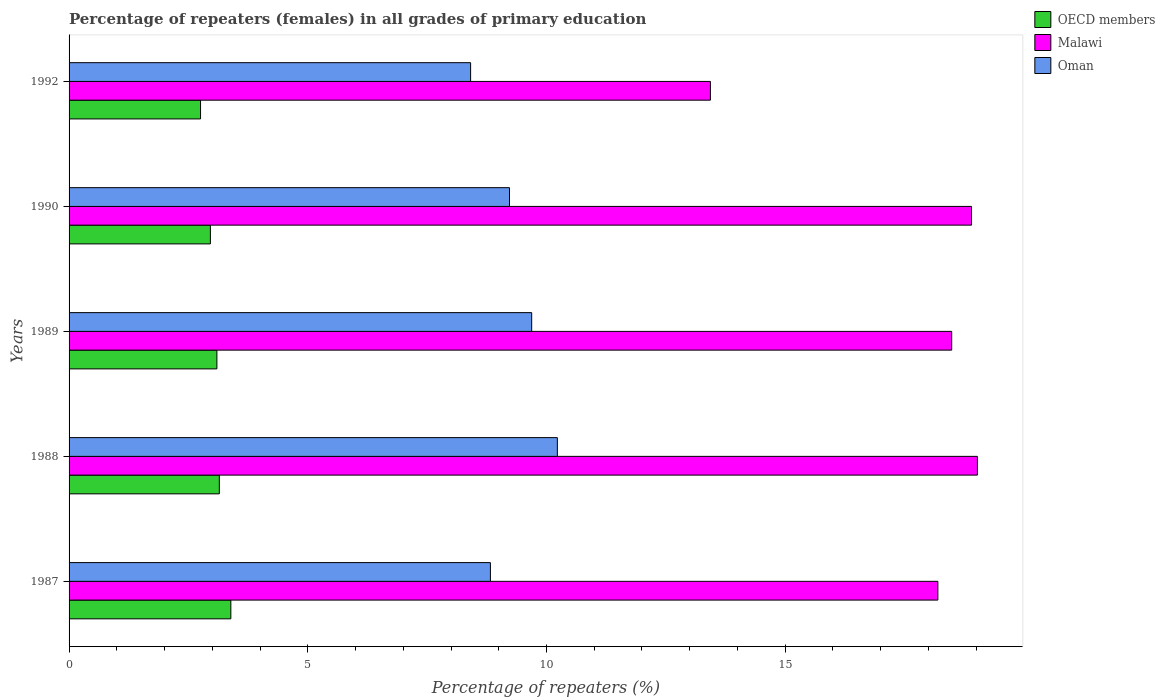How many groups of bars are there?
Give a very brief answer. 5. How many bars are there on the 5th tick from the bottom?
Give a very brief answer. 3. What is the label of the 3rd group of bars from the top?
Offer a terse response. 1989. What is the percentage of repeaters (females) in Malawi in 1992?
Your answer should be very brief. 13.43. Across all years, what is the maximum percentage of repeaters (females) in OECD members?
Ensure brevity in your answer.  3.39. Across all years, what is the minimum percentage of repeaters (females) in OECD members?
Provide a succinct answer. 2.75. What is the total percentage of repeaters (females) in OECD members in the graph?
Provide a succinct answer. 15.35. What is the difference between the percentage of repeaters (females) in OECD members in 1990 and that in 1992?
Provide a succinct answer. 0.21. What is the difference between the percentage of repeaters (females) in OECD members in 1990 and the percentage of repeaters (females) in Malawi in 1989?
Keep it short and to the point. -15.53. What is the average percentage of repeaters (females) in OECD members per year?
Make the answer very short. 3.07. In the year 1992, what is the difference between the percentage of repeaters (females) in Malawi and percentage of repeaters (females) in OECD members?
Provide a short and direct response. 10.68. What is the ratio of the percentage of repeaters (females) in Malawi in 1988 to that in 1992?
Your response must be concise. 1.42. Is the percentage of repeaters (females) in OECD members in 1988 less than that in 1990?
Provide a short and direct response. No. What is the difference between the highest and the second highest percentage of repeaters (females) in Malawi?
Give a very brief answer. 0.12. What is the difference between the highest and the lowest percentage of repeaters (females) in OECD members?
Ensure brevity in your answer.  0.63. In how many years, is the percentage of repeaters (females) in Oman greater than the average percentage of repeaters (females) in Oman taken over all years?
Provide a short and direct response. 2. What does the 2nd bar from the top in 1988 represents?
Offer a terse response. Malawi. What does the 3rd bar from the bottom in 1988 represents?
Keep it short and to the point. Oman. Is it the case that in every year, the sum of the percentage of repeaters (females) in Oman and percentage of repeaters (females) in Malawi is greater than the percentage of repeaters (females) in OECD members?
Provide a succinct answer. Yes. Are all the bars in the graph horizontal?
Your response must be concise. Yes. How many years are there in the graph?
Your answer should be very brief. 5. What is the difference between two consecutive major ticks on the X-axis?
Your answer should be very brief. 5. Does the graph contain any zero values?
Offer a very short reply. No. Does the graph contain grids?
Your answer should be compact. No. Where does the legend appear in the graph?
Give a very brief answer. Top right. How are the legend labels stacked?
Your response must be concise. Vertical. What is the title of the graph?
Offer a terse response. Percentage of repeaters (females) in all grades of primary education. What is the label or title of the X-axis?
Your answer should be compact. Percentage of repeaters (%). What is the Percentage of repeaters (%) in OECD members in 1987?
Give a very brief answer. 3.39. What is the Percentage of repeaters (%) of Malawi in 1987?
Your answer should be very brief. 18.2. What is the Percentage of repeaters (%) in Oman in 1987?
Your answer should be very brief. 8.83. What is the Percentage of repeaters (%) of OECD members in 1988?
Provide a short and direct response. 3.15. What is the Percentage of repeaters (%) of Malawi in 1988?
Make the answer very short. 19.03. What is the Percentage of repeaters (%) of Oman in 1988?
Ensure brevity in your answer.  10.23. What is the Percentage of repeaters (%) in OECD members in 1989?
Offer a very short reply. 3.1. What is the Percentage of repeaters (%) of Malawi in 1989?
Give a very brief answer. 18.49. What is the Percentage of repeaters (%) of Oman in 1989?
Your answer should be very brief. 9.69. What is the Percentage of repeaters (%) in OECD members in 1990?
Make the answer very short. 2.96. What is the Percentage of repeaters (%) of Malawi in 1990?
Make the answer very short. 18.9. What is the Percentage of repeaters (%) of Oman in 1990?
Ensure brevity in your answer.  9.23. What is the Percentage of repeaters (%) of OECD members in 1992?
Keep it short and to the point. 2.75. What is the Percentage of repeaters (%) in Malawi in 1992?
Provide a short and direct response. 13.43. What is the Percentage of repeaters (%) in Oman in 1992?
Give a very brief answer. 8.41. Across all years, what is the maximum Percentage of repeaters (%) of OECD members?
Your answer should be compact. 3.39. Across all years, what is the maximum Percentage of repeaters (%) in Malawi?
Provide a succinct answer. 19.03. Across all years, what is the maximum Percentage of repeaters (%) in Oman?
Provide a succinct answer. 10.23. Across all years, what is the minimum Percentage of repeaters (%) in OECD members?
Your answer should be compact. 2.75. Across all years, what is the minimum Percentage of repeaters (%) in Malawi?
Offer a terse response. 13.43. Across all years, what is the minimum Percentage of repeaters (%) of Oman?
Your response must be concise. 8.41. What is the total Percentage of repeaters (%) of OECD members in the graph?
Give a very brief answer. 15.35. What is the total Percentage of repeaters (%) of Malawi in the graph?
Provide a short and direct response. 88.05. What is the total Percentage of repeaters (%) in Oman in the graph?
Keep it short and to the point. 46.38. What is the difference between the Percentage of repeaters (%) of OECD members in 1987 and that in 1988?
Offer a very short reply. 0.24. What is the difference between the Percentage of repeaters (%) of Malawi in 1987 and that in 1988?
Offer a terse response. -0.83. What is the difference between the Percentage of repeaters (%) of Oman in 1987 and that in 1988?
Make the answer very short. -1.4. What is the difference between the Percentage of repeaters (%) in OECD members in 1987 and that in 1989?
Your answer should be very brief. 0.29. What is the difference between the Percentage of repeaters (%) in Malawi in 1987 and that in 1989?
Provide a short and direct response. -0.29. What is the difference between the Percentage of repeaters (%) in Oman in 1987 and that in 1989?
Make the answer very short. -0.86. What is the difference between the Percentage of repeaters (%) of OECD members in 1987 and that in 1990?
Make the answer very short. 0.43. What is the difference between the Percentage of repeaters (%) in Malawi in 1987 and that in 1990?
Offer a very short reply. -0.7. What is the difference between the Percentage of repeaters (%) in Oman in 1987 and that in 1990?
Provide a short and direct response. -0.4. What is the difference between the Percentage of repeaters (%) in OECD members in 1987 and that in 1992?
Your answer should be compact. 0.63. What is the difference between the Percentage of repeaters (%) in Malawi in 1987 and that in 1992?
Offer a very short reply. 4.76. What is the difference between the Percentage of repeaters (%) in Oman in 1987 and that in 1992?
Offer a terse response. 0.41. What is the difference between the Percentage of repeaters (%) in OECD members in 1988 and that in 1989?
Provide a short and direct response. 0.05. What is the difference between the Percentage of repeaters (%) of Malawi in 1988 and that in 1989?
Your answer should be compact. 0.54. What is the difference between the Percentage of repeaters (%) in Oman in 1988 and that in 1989?
Make the answer very short. 0.54. What is the difference between the Percentage of repeaters (%) of OECD members in 1988 and that in 1990?
Your response must be concise. 0.19. What is the difference between the Percentage of repeaters (%) of Malawi in 1988 and that in 1990?
Ensure brevity in your answer.  0.12. What is the difference between the Percentage of repeaters (%) in Oman in 1988 and that in 1990?
Keep it short and to the point. 1. What is the difference between the Percentage of repeaters (%) of OECD members in 1988 and that in 1992?
Your answer should be compact. 0.39. What is the difference between the Percentage of repeaters (%) in Malawi in 1988 and that in 1992?
Make the answer very short. 5.59. What is the difference between the Percentage of repeaters (%) in Oman in 1988 and that in 1992?
Offer a terse response. 1.82. What is the difference between the Percentage of repeaters (%) of OECD members in 1989 and that in 1990?
Keep it short and to the point. 0.14. What is the difference between the Percentage of repeaters (%) in Malawi in 1989 and that in 1990?
Give a very brief answer. -0.41. What is the difference between the Percentage of repeaters (%) in Oman in 1989 and that in 1990?
Offer a very short reply. 0.46. What is the difference between the Percentage of repeaters (%) of OECD members in 1989 and that in 1992?
Offer a very short reply. 0.34. What is the difference between the Percentage of repeaters (%) of Malawi in 1989 and that in 1992?
Keep it short and to the point. 5.05. What is the difference between the Percentage of repeaters (%) of Oman in 1989 and that in 1992?
Your answer should be very brief. 1.28. What is the difference between the Percentage of repeaters (%) of OECD members in 1990 and that in 1992?
Provide a succinct answer. 0.21. What is the difference between the Percentage of repeaters (%) of Malawi in 1990 and that in 1992?
Give a very brief answer. 5.47. What is the difference between the Percentage of repeaters (%) in Oman in 1990 and that in 1992?
Give a very brief answer. 0.81. What is the difference between the Percentage of repeaters (%) of OECD members in 1987 and the Percentage of repeaters (%) of Malawi in 1988?
Your response must be concise. -15.64. What is the difference between the Percentage of repeaters (%) of OECD members in 1987 and the Percentage of repeaters (%) of Oman in 1988?
Keep it short and to the point. -6.84. What is the difference between the Percentage of repeaters (%) in Malawi in 1987 and the Percentage of repeaters (%) in Oman in 1988?
Offer a terse response. 7.97. What is the difference between the Percentage of repeaters (%) in OECD members in 1987 and the Percentage of repeaters (%) in Malawi in 1989?
Give a very brief answer. -15.1. What is the difference between the Percentage of repeaters (%) of OECD members in 1987 and the Percentage of repeaters (%) of Oman in 1989?
Provide a short and direct response. -6.3. What is the difference between the Percentage of repeaters (%) of Malawi in 1987 and the Percentage of repeaters (%) of Oman in 1989?
Keep it short and to the point. 8.51. What is the difference between the Percentage of repeaters (%) in OECD members in 1987 and the Percentage of repeaters (%) in Malawi in 1990?
Offer a very short reply. -15.51. What is the difference between the Percentage of repeaters (%) of OECD members in 1987 and the Percentage of repeaters (%) of Oman in 1990?
Offer a very short reply. -5.84. What is the difference between the Percentage of repeaters (%) of Malawi in 1987 and the Percentage of repeaters (%) of Oman in 1990?
Your answer should be compact. 8.97. What is the difference between the Percentage of repeaters (%) of OECD members in 1987 and the Percentage of repeaters (%) of Malawi in 1992?
Give a very brief answer. -10.05. What is the difference between the Percentage of repeaters (%) of OECD members in 1987 and the Percentage of repeaters (%) of Oman in 1992?
Offer a terse response. -5.02. What is the difference between the Percentage of repeaters (%) in Malawi in 1987 and the Percentage of repeaters (%) in Oman in 1992?
Your response must be concise. 9.79. What is the difference between the Percentage of repeaters (%) in OECD members in 1988 and the Percentage of repeaters (%) in Malawi in 1989?
Ensure brevity in your answer.  -15.34. What is the difference between the Percentage of repeaters (%) in OECD members in 1988 and the Percentage of repeaters (%) in Oman in 1989?
Keep it short and to the point. -6.54. What is the difference between the Percentage of repeaters (%) in Malawi in 1988 and the Percentage of repeaters (%) in Oman in 1989?
Give a very brief answer. 9.34. What is the difference between the Percentage of repeaters (%) of OECD members in 1988 and the Percentage of repeaters (%) of Malawi in 1990?
Offer a very short reply. -15.76. What is the difference between the Percentage of repeaters (%) of OECD members in 1988 and the Percentage of repeaters (%) of Oman in 1990?
Provide a short and direct response. -6.08. What is the difference between the Percentage of repeaters (%) of Malawi in 1988 and the Percentage of repeaters (%) of Oman in 1990?
Make the answer very short. 9.8. What is the difference between the Percentage of repeaters (%) of OECD members in 1988 and the Percentage of repeaters (%) of Malawi in 1992?
Your response must be concise. -10.29. What is the difference between the Percentage of repeaters (%) in OECD members in 1988 and the Percentage of repeaters (%) in Oman in 1992?
Ensure brevity in your answer.  -5.26. What is the difference between the Percentage of repeaters (%) of Malawi in 1988 and the Percentage of repeaters (%) of Oman in 1992?
Your response must be concise. 10.62. What is the difference between the Percentage of repeaters (%) of OECD members in 1989 and the Percentage of repeaters (%) of Malawi in 1990?
Offer a terse response. -15.81. What is the difference between the Percentage of repeaters (%) of OECD members in 1989 and the Percentage of repeaters (%) of Oman in 1990?
Offer a very short reply. -6.13. What is the difference between the Percentage of repeaters (%) in Malawi in 1989 and the Percentage of repeaters (%) in Oman in 1990?
Your answer should be compact. 9.26. What is the difference between the Percentage of repeaters (%) of OECD members in 1989 and the Percentage of repeaters (%) of Malawi in 1992?
Provide a succinct answer. -10.34. What is the difference between the Percentage of repeaters (%) in OECD members in 1989 and the Percentage of repeaters (%) in Oman in 1992?
Give a very brief answer. -5.31. What is the difference between the Percentage of repeaters (%) of Malawi in 1989 and the Percentage of repeaters (%) of Oman in 1992?
Your answer should be compact. 10.08. What is the difference between the Percentage of repeaters (%) of OECD members in 1990 and the Percentage of repeaters (%) of Malawi in 1992?
Your answer should be very brief. -10.47. What is the difference between the Percentage of repeaters (%) in OECD members in 1990 and the Percentage of repeaters (%) in Oman in 1992?
Your answer should be compact. -5.45. What is the difference between the Percentage of repeaters (%) in Malawi in 1990 and the Percentage of repeaters (%) in Oman in 1992?
Give a very brief answer. 10.49. What is the average Percentage of repeaters (%) in OECD members per year?
Your response must be concise. 3.07. What is the average Percentage of repeaters (%) of Malawi per year?
Your response must be concise. 17.61. What is the average Percentage of repeaters (%) in Oman per year?
Give a very brief answer. 9.28. In the year 1987, what is the difference between the Percentage of repeaters (%) of OECD members and Percentage of repeaters (%) of Malawi?
Provide a succinct answer. -14.81. In the year 1987, what is the difference between the Percentage of repeaters (%) of OECD members and Percentage of repeaters (%) of Oman?
Make the answer very short. -5.44. In the year 1987, what is the difference between the Percentage of repeaters (%) of Malawi and Percentage of repeaters (%) of Oman?
Your answer should be very brief. 9.37. In the year 1988, what is the difference between the Percentage of repeaters (%) of OECD members and Percentage of repeaters (%) of Malawi?
Keep it short and to the point. -15.88. In the year 1988, what is the difference between the Percentage of repeaters (%) in OECD members and Percentage of repeaters (%) in Oman?
Give a very brief answer. -7.08. In the year 1988, what is the difference between the Percentage of repeaters (%) in Malawi and Percentage of repeaters (%) in Oman?
Your response must be concise. 8.8. In the year 1989, what is the difference between the Percentage of repeaters (%) of OECD members and Percentage of repeaters (%) of Malawi?
Provide a succinct answer. -15.39. In the year 1989, what is the difference between the Percentage of repeaters (%) of OECD members and Percentage of repeaters (%) of Oman?
Your answer should be very brief. -6.59. In the year 1989, what is the difference between the Percentage of repeaters (%) in Malawi and Percentage of repeaters (%) in Oman?
Ensure brevity in your answer.  8.8. In the year 1990, what is the difference between the Percentage of repeaters (%) in OECD members and Percentage of repeaters (%) in Malawi?
Your answer should be very brief. -15.94. In the year 1990, what is the difference between the Percentage of repeaters (%) in OECD members and Percentage of repeaters (%) in Oman?
Your answer should be very brief. -6.27. In the year 1990, what is the difference between the Percentage of repeaters (%) in Malawi and Percentage of repeaters (%) in Oman?
Give a very brief answer. 9.68. In the year 1992, what is the difference between the Percentage of repeaters (%) of OECD members and Percentage of repeaters (%) of Malawi?
Give a very brief answer. -10.68. In the year 1992, what is the difference between the Percentage of repeaters (%) in OECD members and Percentage of repeaters (%) in Oman?
Your response must be concise. -5.66. In the year 1992, what is the difference between the Percentage of repeaters (%) in Malawi and Percentage of repeaters (%) in Oman?
Make the answer very short. 5.02. What is the ratio of the Percentage of repeaters (%) in OECD members in 1987 to that in 1988?
Provide a succinct answer. 1.08. What is the ratio of the Percentage of repeaters (%) in Malawi in 1987 to that in 1988?
Make the answer very short. 0.96. What is the ratio of the Percentage of repeaters (%) of Oman in 1987 to that in 1988?
Your answer should be very brief. 0.86. What is the ratio of the Percentage of repeaters (%) of OECD members in 1987 to that in 1989?
Give a very brief answer. 1.09. What is the ratio of the Percentage of repeaters (%) in Malawi in 1987 to that in 1989?
Your answer should be very brief. 0.98. What is the ratio of the Percentage of repeaters (%) in Oman in 1987 to that in 1989?
Ensure brevity in your answer.  0.91. What is the ratio of the Percentage of repeaters (%) of OECD members in 1987 to that in 1990?
Keep it short and to the point. 1.14. What is the ratio of the Percentage of repeaters (%) of Malawi in 1987 to that in 1990?
Provide a succinct answer. 0.96. What is the ratio of the Percentage of repeaters (%) of Oman in 1987 to that in 1990?
Ensure brevity in your answer.  0.96. What is the ratio of the Percentage of repeaters (%) of OECD members in 1987 to that in 1992?
Ensure brevity in your answer.  1.23. What is the ratio of the Percentage of repeaters (%) of Malawi in 1987 to that in 1992?
Keep it short and to the point. 1.35. What is the ratio of the Percentage of repeaters (%) in Oman in 1987 to that in 1992?
Your answer should be compact. 1.05. What is the ratio of the Percentage of repeaters (%) of OECD members in 1988 to that in 1989?
Your response must be concise. 1.02. What is the ratio of the Percentage of repeaters (%) in Malawi in 1988 to that in 1989?
Your answer should be compact. 1.03. What is the ratio of the Percentage of repeaters (%) in Oman in 1988 to that in 1989?
Give a very brief answer. 1.06. What is the ratio of the Percentage of repeaters (%) in OECD members in 1988 to that in 1990?
Your answer should be compact. 1.06. What is the ratio of the Percentage of repeaters (%) of Malawi in 1988 to that in 1990?
Keep it short and to the point. 1.01. What is the ratio of the Percentage of repeaters (%) of Oman in 1988 to that in 1990?
Your answer should be compact. 1.11. What is the ratio of the Percentage of repeaters (%) of OECD members in 1988 to that in 1992?
Your answer should be compact. 1.14. What is the ratio of the Percentage of repeaters (%) in Malawi in 1988 to that in 1992?
Provide a succinct answer. 1.42. What is the ratio of the Percentage of repeaters (%) of Oman in 1988 to that in 1992?
Keep it short and to the point. 1.22. What is the ratio of the Percentage of repeaters (%) in OECD members in 1989 to that in 1990?
Offer a terse response. 1.05. What is the ratio of the Percentage of repeaters (%) in Malawi in 1989 to that in 1990?
Keep it short and to the point. 0.98. What is the ratio of the Percentage of repeaters (%) in Oman in 1989 to that in 1990?
Your answer should be compact. 1.05. What is the ratio of the Percentage of repeaters (%) in OECD members in 1989 to that in 1992?
Provide a short and direct response. 1.12. What is the ratio of the Percentage of repeaters (%) in Malawi in 1989 to that in 1992?
Give a very brief answer. 1.38. What is the ratio of the Percentage of repeaters (%) of Oman in 1989 to that in 1992?
Provide a short and direct response. 1.15. What is the ratio of the Percentage of repeaters (%) in OECD members in 1990 to that in 1992?
Give a very brief answer. 1.07. What is the ratio of the Percentage of repeaters (%) in Malawi in 1990 to that in 1992?
Offer a very short reply. 1.41. What is the ratio of the Percentage of repeaters (%) in Oman in 1990 to that in 1992?
Give a very brief answer. 1.1. What is the difference between the highest and the second highest Percentage of repeaters (%) of OECD members?
Ensure brevity in your answer.  0.24. What is the difference between the highest and the second highest Percentage of repeaters (%) in Malawi?
Your answer should be compact. 0.12. What is the difference between the highest and the second highest Percentage of repeaters (%) in Oman?
Provide a short and direct response. 0.54. What is the difference between the highest and the lowest Percentage of repeaters (%) in OECD members?
Ensure brevity in your answer.  0.63. What is the difference between the highest and the lowest Percentage of repeaters (%) in Malawi?
Your answer should be compact. 5.59. What is the difference between the highest and the lowest Percentage of repeaters (%) of Oman?
Offer a terse response. 1.82. 